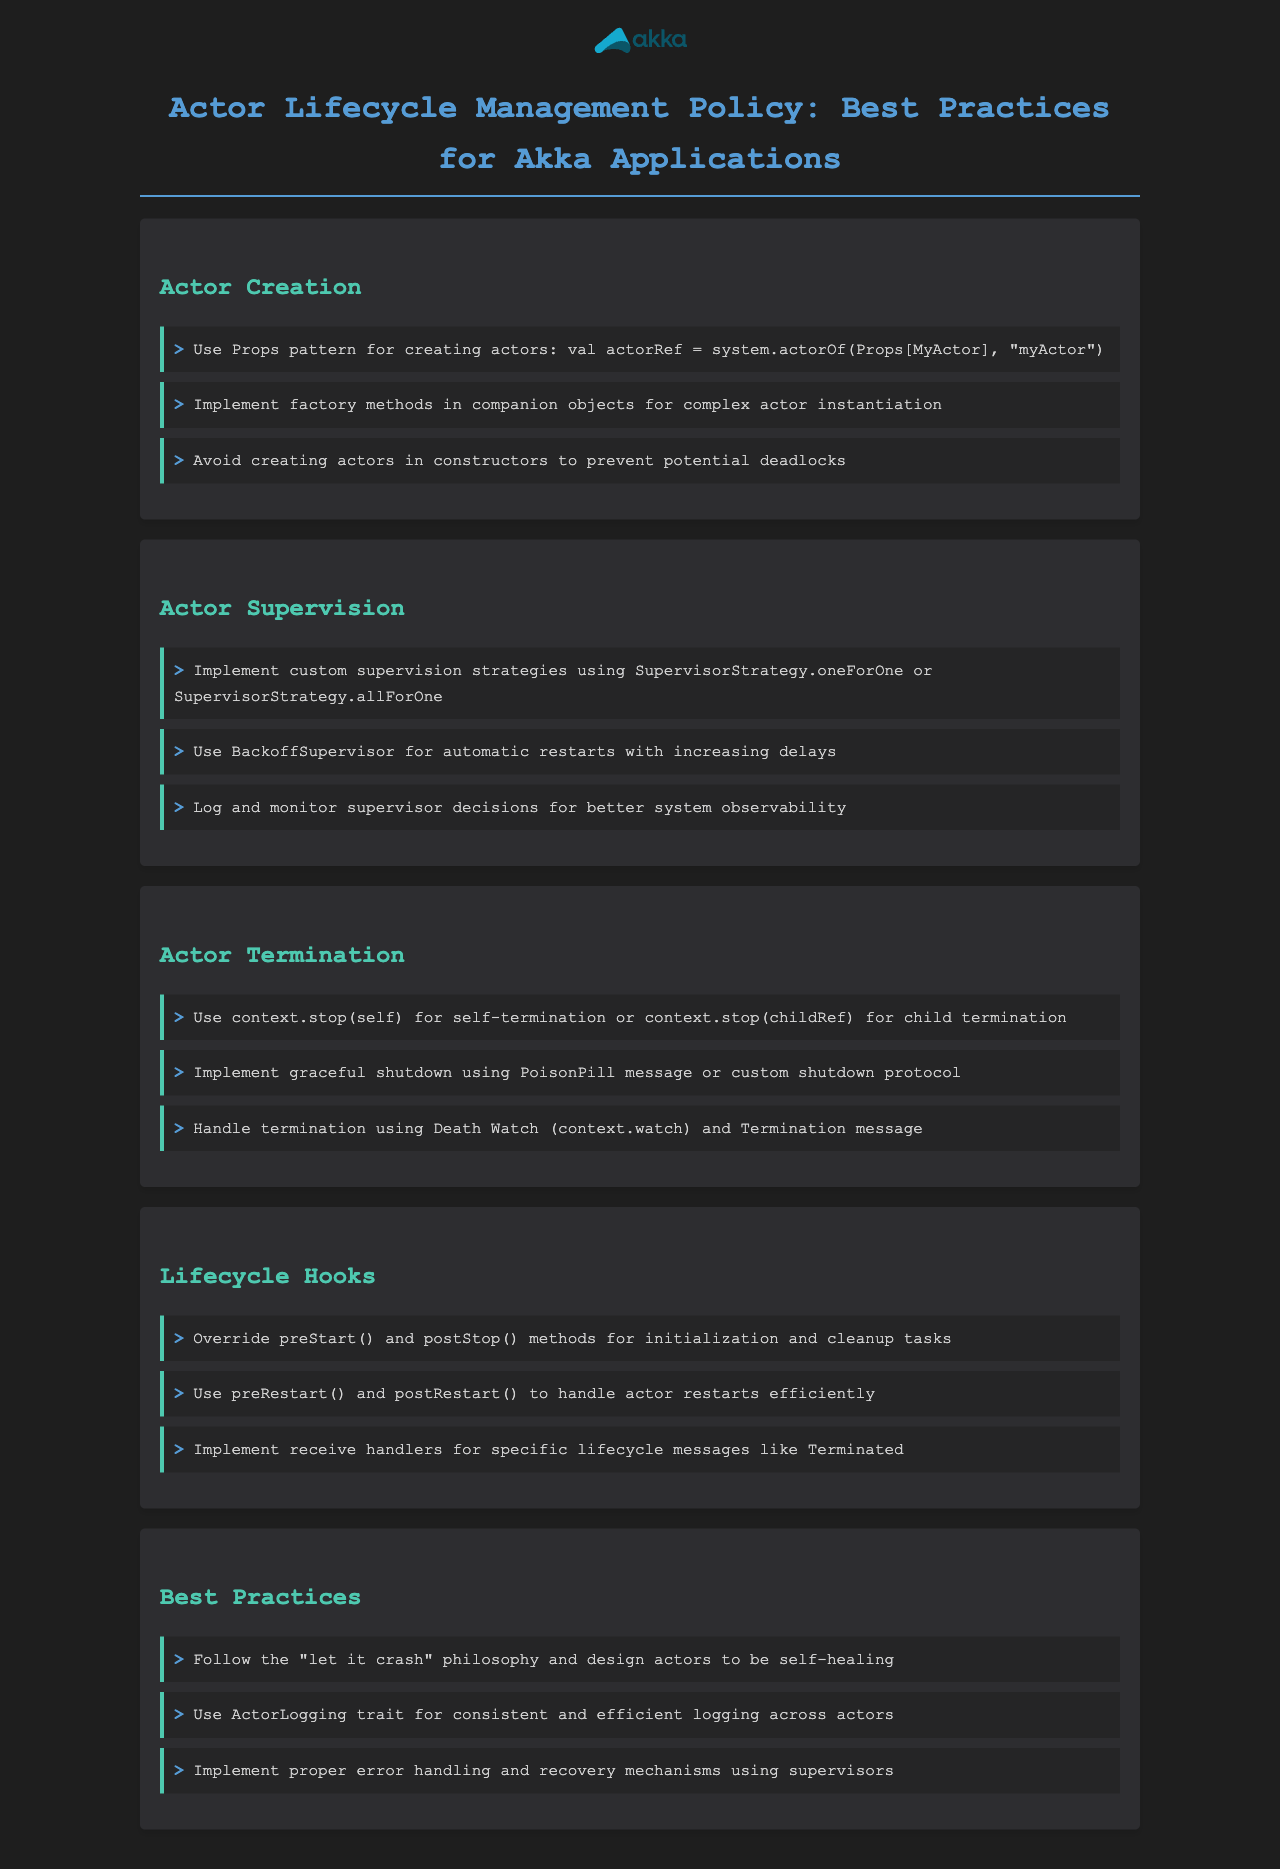What is the primary method for actor creation? The primary method for creating actors is demonstrated using the Props pattern in the document.
Answer: Props pattern What is the purpose of using BackoffSupervisor? BackoffSupervisor is used for automatic restarts with increasing delays as mentioned in the supervision section.
Answer: Automatic restarts What message can be used for graceful shutdown? The document states that a PoisonPill message can be used for graceful shutdown.
Answer: PoisonPill Which lifecycle hook is called after an actor is stopped? The lifecycle hook that is called after an actor is stopped is mentioned as postStop in the document.
Answer: postStop What is a recommended error handling philosophy for actors? The document suggests following the "let it crash" philosophy for error handling.
Answer: Let it crash What coding patterns should be avoided when creating actors? The document advises against creating actors in constructors to avoid potential deadlocks.
Answer: Creating actors in constructors What strategy can be implemented for supervising failures? Custom supervision strategies such as SupervisorStrategy.oneForOne or SupervisorStrategy.allForOne can be implemented as per the document.
Answer: Custom supervision strategies What should be logged for better system observability? The document emphasizes logging and monitoring supervisor decisions for improved observability.
Answer: Supervisor decisions Which trait is recommended for logging in actors? ActorLogging trait is recommended for consistent and efficient logging across actors according to the best practices section.
Answer: ActorLogging trait 